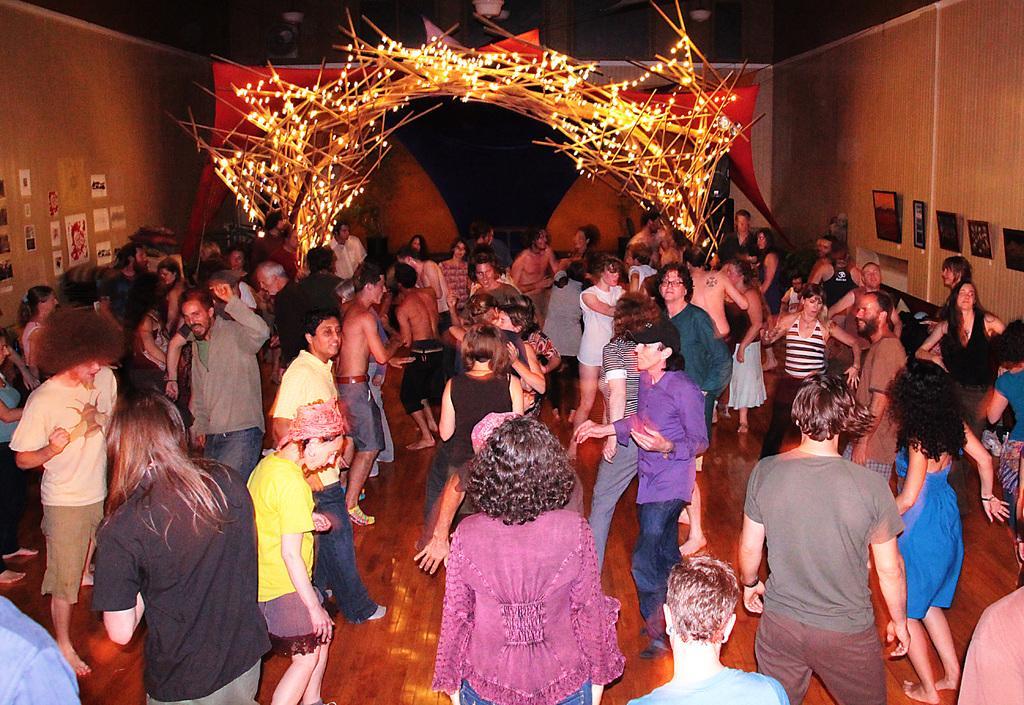Can you describe this image briefly? In this image there are group of persons standing and dancing and on the right side there are black colour objects hanging on the wall. In the center on the top there is an arch and there are lights. On the left side there are posters on the wall. 